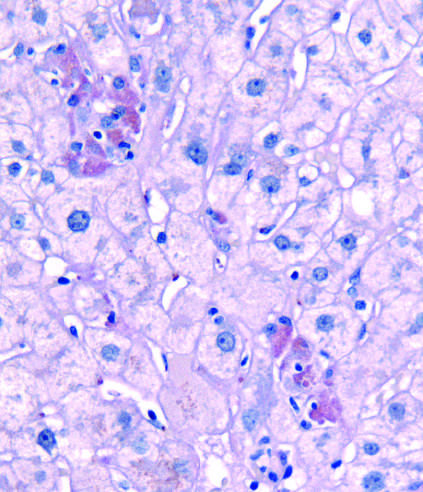what stain is seen after diastase digestion?
Answer the question using a single word or phrase. Pas-d 